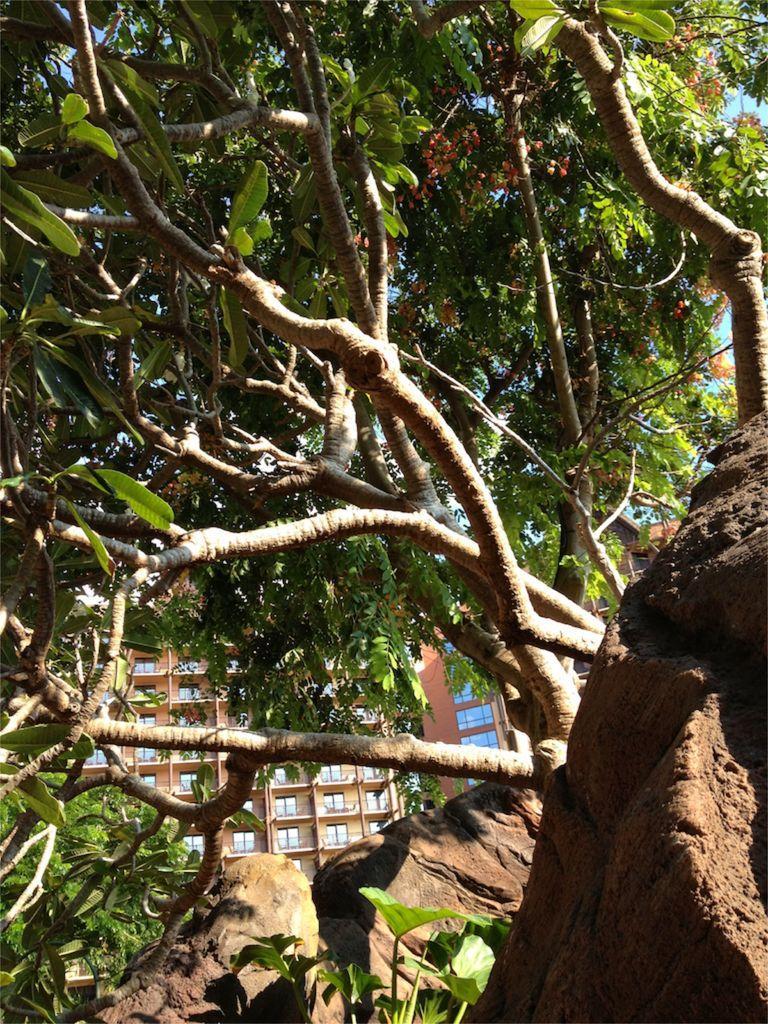Could you give a brief overview of what you see in this image? This image consists of trees and buildings. At the bottom, there are rocks. 